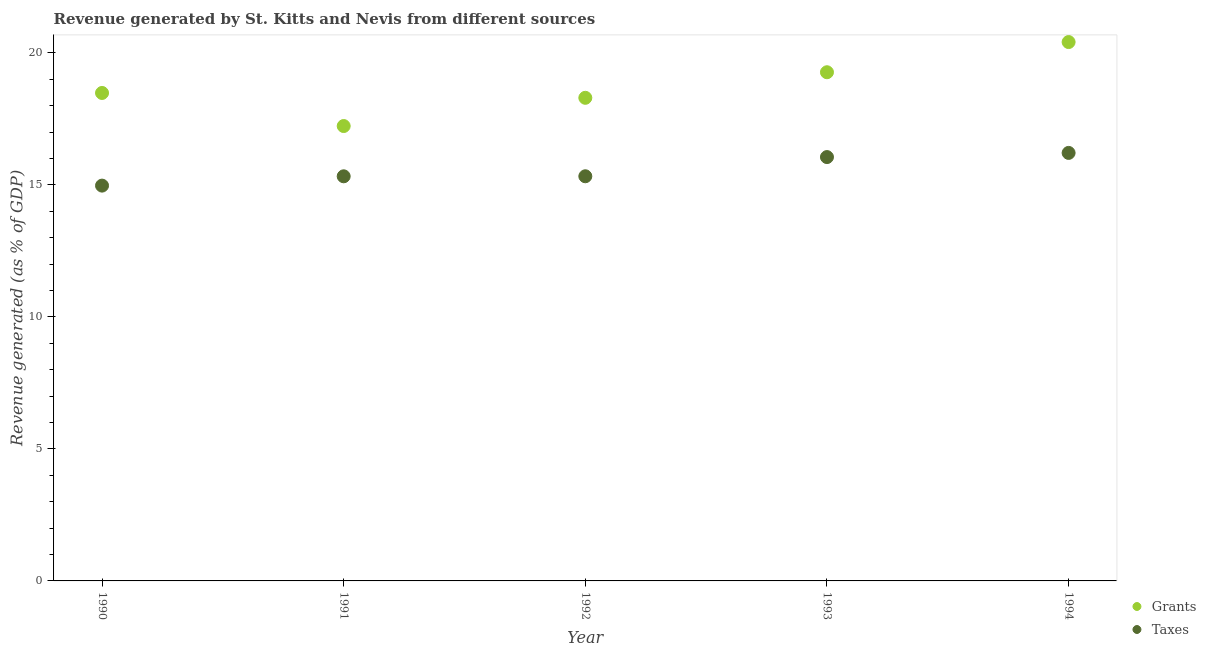How many different coloured dotlines are there?
Your answer should be very brief. 2. What is the revenue generated by taxes in 1993?
Your answer should be very brief. 16.05. Across all years, what is the maximum revenue generated by grants?
Offer a very short reply. 20.41. Across all years, what is the minimum revenue generated by taxes?
Make the answer very short. 14.97. In which year was the revenue generated by taxes maximum?
Offer a terse response. 1994. What is the total revenue generated by taxes in the graph?
Ensure brevity in your answer.  77.89. What is the difference between the revenue generated by grants in 1990 and that in 1994?
Provide a succinct answer. -1.93. What is the difference between the revenue generated by grants in 1994 and the revenue generated by taxes in 1990?
Provide a short and direct response. 5.44. What is the average revenue generated by grants per year?
Your answer should be compact. 18.74. In the year 1994, what is the difference between the revenue generated by grants and revenue generated by taxes?
Give a very brief answer. 4.2. In how many years, is the revenue generated by taxes greater than 18 %?
Make the answer very short. 0. What is the ratio of the revenue generated by taxes in 1991 to that in 1993?
Offer a very short reply. 0.95. What is the difference between the highest and the second highest revenue generated by taxes?
Make the answer very short. 0.16. What is the difference between the highest and the lowest revenue generated by taxes?
Offer a terse response. 1.24. Is the sum of the revenue generated by taxes in 1993 and 1994 greater than the maximum revenue generated by grants across all years?
Provide a short and direct response. Yes. Does the revenue generated by taxes monotonically increase over the years?
Provide a succinct answer. Yes. Is the revenue generated by grants strictly greater than the revenue generated by taxes over the years?
Ensure brevity in your answer.  Yes. How many dotlines are there?
Your answer should be compact. 2. How many years are there in the graph?
Keep it short and to the point. 5. What is the difference between two consecutive major ticks on the Y-axis?
Keep it short and to the point. 5. Does the graph contain any zero values?
Your response must be concise. No. Does the graph contain grids?
Provide a short and direct response. No. Where does the legend appear in the graph?
Your answer should be compact. Bottom right. How are the legend labels stacked?
Offer a very short reply. Vertical. What is the title of the graph?
Provide a succinct answer. Revenue generated by St. Kitts and Nevis from different sources. What is the label or title of the Y-axis?
Give a very brief answer. Revenue generated (as % of GDP). What is the Revenue generated (as % of GDP) of Grants in 1990?
Your answer should be very brief. 18.48. What is the Revenue generated (as % of GDP) of Taxes in 1990?
Your response must be concise. 14.97. What is the Revenue generated (as % of GDP) of Grants in 1991?
Provide a succinct answer. 17.23. What is the Revenue generated (as % of GDP) in Taxes in 1991?
Offer a very short reply. 15.33. What is the Revenue generated (as % of GDP) of Grants in 1992?
Provide a short and direct response. 18.3. What is the Revenue generated (as % of GDP) of Taxes in 1992?
Provide a short and direct response. 15.33. What is the Revenue generated (as % of GDP) in Grants in 1993?
Provide a succinct answer. 19.27. What is the Revenue generated (as % of GDP) of Taxes in 1993?
Your answer should be compact. 16.05. What is the Revenue generated (as % of GDP) in Grants in 1994?
Provide a short and direct response. 20.41. What is the Revenue generated (as % of GDP) in Taxes in 1994?
Offer a very short reply. 16.21. Across all years, what is the maximum Revenue generated (as % of GDP) in Grants?
Your answer should be very brief. 20.41. Across all years, what is the maximum Revenue generated (as % of GDP) in Taxes?
Ensure brevity in your answer.  16.21. Across all years, what is the minimum Revenue generated (as % of GDP) of Grants?
Your answer should be compact. 17.23. Across all years, what is the minimum Revenue generated (as % of GDP) in Taxes?
Make the answer very short. 14.97. What is the total Revenue generated (as % of GDP) of Grants in the graph?
Give a very brief answer. 93.69. What is the total Revenue generated (as % of GDP) of Taxes in the graph?
Your response must be concise. 77.89. What is the difference between the Revenue generated (as % of GDP) in Grants in 1990 and that in 1991?
Your answer should be compact. 1.25. What is the difference between the Revenue generated (as % of GDP) in Taxes in 1990 and that in 1991?
Your answer should be very brief. -0.35. What is the difference between the Revenue generated (as % of GDP) of Grants in 1990 and that in 1992?
Keep it short and to the point. 0.18. What is the difference between the Revenue generated (as % of GDP) in Taxes in 1990 and that in 1992?
Provide a succinct answer. -0.35. What is the difference between the Revenue generated (as % of GDP) of Grants in 1990 and that in 1993?
Your answer should be very brief. -0.78. What is the difference between the Revenue generated (as % of GDP) of Taxes in 1990 and that in 1993?
Offer a terse response. -1.08. What is the difference between the Revenue generated (as % of GDP) in Grants in 1990 and that in 1994?
Offer a very short reply. -1.93. What is the difference between the Revenue generated (as % of GDP) in Taxes in 1990 and that in 1994?
Your response must be concise. -1.24. What is the difference between the Revenue generated (as % of GDP) of Grants in 1991 and that in 1992?
Give a very brief answer. -1.07. What is the difference between the Revenue generated (as % of GDP) of Taxes in 1991 and that in 1992?
Make the answer very short. -0. What is the difference between the Revenue generated (as % of GDP) of Grants in 1991 and that in 1993?
Give a very brief answer. -2.04. What is the difference between the Revenue generated (as % of GDP) in Taxes in 1991 and that in 1993?
Offer a very short reply. -0.73. What is the difference between the Revenue generated (as % of GDP) in Grants in 1991 and that in 1994?
Provide a succinct answer. -3.18. What is the difference between the Revenue generated (as % of GDP) in Taxes in 1991 and that in 1994?
Make the answer very short. -0.89. What is the difference between the Revenue generated (as % of GDP) of Grants in 1992 and that in 1993?
Your answer should be compact. -0.97. What is the difference between the Revenue generated (as % of GDP) of Taxes in 1992 and that in 1993?
Give a very brief answer. -0.73. What is the difference between the Revenue generated (as % of GDP) of Grants in 1992 and that in 1994?
Ensure brevity in your answer.  -2.11. What is the difference between the Revenue generated (as % of GDP) of Taxes in 1992 and that in 1994?
Offer a terse response. -0.88. What is the difference between the Revenue generated (as % of GDP) in Grants in 1993 and that in 1994?
Keep it short and to the point. -1.14. What is the difference between the Revenue generated (as % of GDP) in Taxes in 1993 and that in 1994?
Ensure brevity in your answer.  -0.16. What is the difference between the Revenue generated (as % of GDP) in Grants in 1990 and the Revenue generated (as % of GDP) in Taxes in 1991?
Give a very brief answer. 3.16. What is the difference between the Revenue generated (as % of GDP) in Grants in 1990 and the Revenue generated (as % of GDP) in Taxes in 1992?
Make the answer very short. 3.16. What is the difference between the Revenue generated (as % of GDP) of Grants in 1990 and the Revenue generated (as % of GDP) of Taxes in 1993?
Provide a short and direct response. 2.43. What is the difference between the Revenue generated (as % of GDP) in Grants in 1990 and the Revenue generated (as % of GDP) in Taxes in 1994?
Your answer should be very brief. 2.27. What is the difference between the Revenue generated (as % of GDP) in Grants in 1991 and the Revenue generated (as % of GDP) in Taxes in 1992?
Your answer should be very brief. 1.9. What is the difference between the Revenue generated (as % of GDP) in Grants in 1991 and the Revenue generated (as % of GDP) in Taxes in 1993?
Provide a short and direct response. 1.18. What is the difference between the Revenue generated (as % of GDP) in Grants in 1991 and the Revenue generated (as % of GDP) in Taxes in 1994?
Your answer should be very brief. 1.02. What is the difference between the Revenue generated (as % of GDP) of Grants in 1992 and the Revenue generated (as % of GDP) of Taxes in 1993?
Your answer should be very brief. 2.24. What is the difference between the Revenue generated (as % of GDP) in Grants in 1992 and the Revenue generated (as % of GDP) in Taxes in 1994?
Your response must be concise. 2.09. What is the difference between the Revenue generated (as % of GDP) in Grants in 1993 and the Revenue generated (as % of GDP) in Taxes in 1994?
Provide a succinct answer. 3.06. What is the average Revenue generated (as % of GDP) in Grants per year?
Your response must be concise. 18.74. What is the average Revenue generated (as % of GDP) of Taxes per year?
Provide a short and direct response. 15.58. In the year 1990, what is the difference between the Revenue generated (as % of GDP) in Grants and Revenue generated (as % of GDP) in Taxes?
Your answer should be very brief. 3.51. In the year 1991, what is the difference between the Revenue generated (as % of GDP) in Grants and Revenue generated (as % of GDP) in Taxes?
Your answer should be very brief. 1.9. In the year 1992, what is the difference between the Revenue generated (as % of GDP) in Grants and Revenue generated (as % of GDP) in Taxes?
Offer a very short reply. 2.97. In the year 1993, what is the difference between the Revenue generated (as % of GDP) of Grants and Revenue generated (as % of GDP) of Taxes?
Give a very brief answer. 3.21. In the year 1994, what is the difference between the Revenue generated (as % of GDP) in Grants and Revenue generated (as % of GDP) in Taxes?
Ensure brevity in your answer.  4.2. What is the ratio of the Revenue generated (as % of GDP) of Grants in 1990 to that in 1991?
Your response must be concise. 1.07. What is the ratio of the Revenue generated (as % of GDP) of Taxes in 1990 to that in 1991?
Keep it short and to the point. 0.98. What is the ratio of the Revenue generated (as % of GDP) in Grants in 1990 to that in 1992?
Offer a very short reply. 1.01. What is the ratio of the Revenue generated (as % of GDP) in Taxes in 1990 to that in 1992?
Make the answer very short. 0.98. What is the ratio of the Revenue generated (as % of GDP) of Grants in 1990 to that in 1993?
Your answer should be very brief. 0.96. What is the ratio of the Revenue generated (as % of GDP) in Taxes in 1990 to that in 1993?
Provide a succinct answer. 0.93. What is the ratio of the Revenue generated (as % of GDP) of Grants in 1990 to that in 1994?
Make the answer very short. 0.91. What is the ratio of the Revenue generated (as % of GDP) in Taxes in 1990 to that in 1994?
Provide a short and direct response. 0.92. What is the ratio of the Revenue generated (as % of GDP) of Grants in 1991 to that in 1992?
Give a very brief answer. 0.94. What is the ratio of the Revenue generated (as % of GDP) in Grants in 1991 to that in 1993?
Provide a short and direct response. 0.89. What is the ratio of the Revenue generated (as % of GDP) of Taxes in 1991 to that in 1993?
Offer a very short reply. 0.95. What is the ratio of the Revenue generated (as % of GDP) in Grants in 1991 to that in 1994?
Make the answer very short. 0.84. What is the ratio of the Revenue generated (as % of GDP) of Taxes in 1991 to that in 1994?
Give a very brief answer. 0.95. What is the ratio of the Revenue generated (as % of GDP) in Grants in 1992 to that in 1993?
Your answer should be very brief. 0.95. What is the ratio of the Revenue generated (as % of GDP) in Taxes in 1992 to that in 1993?
Provide a succinct answer. 0.95. What is the ratio of the Revenue generated (as % of GDP) in Grants in 1992 to that in 1994?
Make the answer very short. 0.9. What is the ratio of the Revenue generated (as % of GDP) of Taxes in 1992 to that in 1994?
Make the answer very short. 0.95. What is the ratio of the Revenue generated (as % of GDP) of Grants in 1993 to that in 1994?
Offer a terse response. 0.94. What is the ratio of the Revenue generated (as % of GDP) in Taxes in 1993 to that in 1994?
Offer a very short reply. 0.99. What is the difference between the highest and the second highest Revenue generated (as % of GDP) in Grants?
Offer a terse response. 1.14. What is the difference between the highest and the second highest Revenue generated (as % of GDP) of Taxes?
Ensure brevity in your answer.  0.16. What is the difference between the highest and the lowest Revenue generated (as % of GDP) of Grants?
Offer a very short reply. 3.18. What is the difference between the highest and the lowest Revenue generated (as % of GDP) in Taxes?
Ensure brevity in your answer.  1.24. 